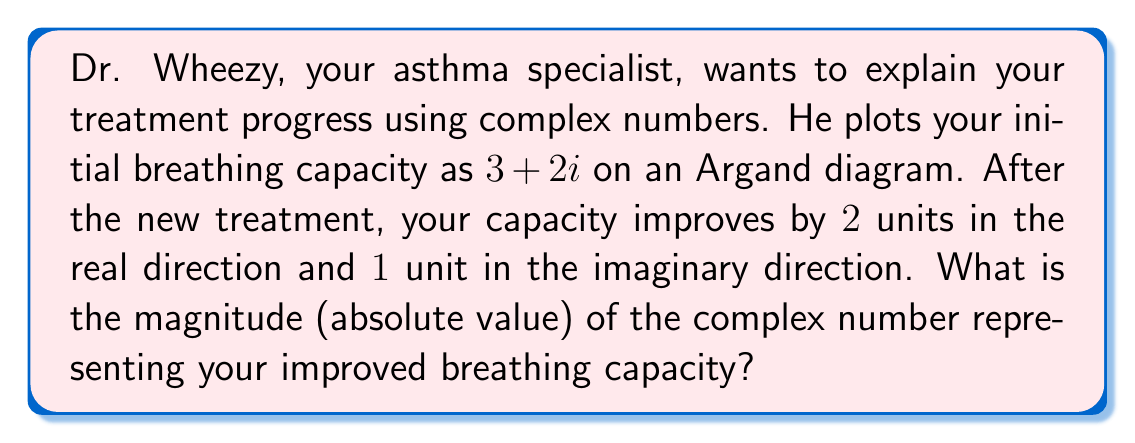Provide a solution to this math problem. Let's approach this step-by-step:

1) Your initial breathing capacity is represented by the complex number $z_1 = 3+2i$.

2) The improvement is represented by $2+i$.

3) Your new breathing capacity is the sum of these complex numbers:
   $z_2 = z_1 + (2+i) = (3+2i) + (2+i) = 5+3i$

4) To find the magnitude of $z_2$, we use the formula:
   $|z| = \sqrt{a^2 + b^2}$, where $z = a+bi$

5) In this case, $a=5$ and $b=3$:
   $|z_2| = \sqrt{5^2 + 3^2}$

6) Simplify:
   $|z_2| = \sqrt{25 + 9} = \sqrt{34}$

7) The square root of 34 cannot be simplified further.

Therefore, the magnitude of your improved breathing capacity is $\sqrt{34}$.

[asy]
import geometry;

size(200);
real xmax = 6;
real ymax = 4;

xaxis("Re(z)", -1, xmax, arrow=Arrow);
yaxis("Im(z)", -1, ymax, arrow=Arrow);

dot("$3+2i$", (3,2), NE);
dot("$5+3i$", (5,3), NE);

draw((0,0)--(5,3), arrow=Arrow);
draw((3,2)--(5,3), arrow=Arrow, dashed);

label("$2+i$", (4,2.5), SE);
[/asy]
Answer: $\sqrt{34}$ 